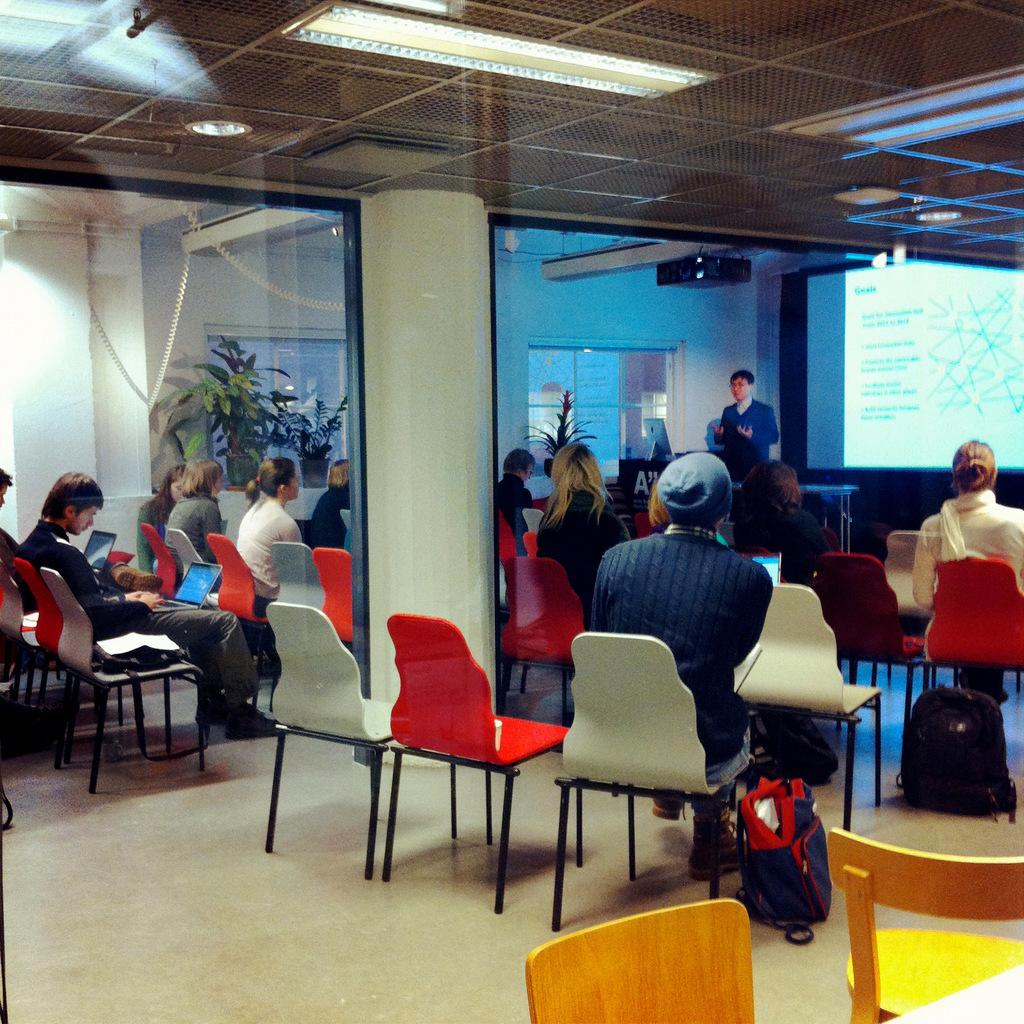What are the people in the image doing? The people in the image are sitting on chairs. Is there anyone else in the image besides the people sitting on chairs? Yes, there is a man standing in front of the people in the image. How many bombs can be seen in the image? There are no bombs present in the image. What type of shoes are the people wearing in the image? The facts provided do not mention the type of shoes the people are wearing, so we cannot answer this question definitively. 